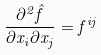Convert formula to latex. <formula><loc_0><loc_0><loc_500><loc_500>\frac { \partial ^ { 2 } \hat { f } } { \partial x _ { i } \partial x _ { j } } = f ^ { i j }</formula> 